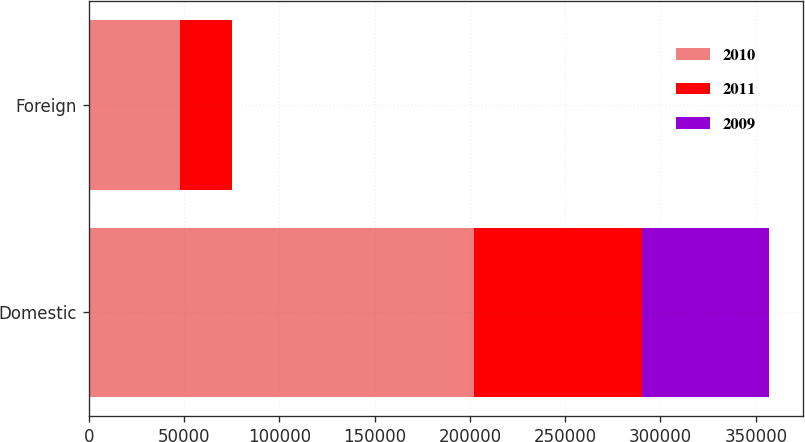Convert chart. <chart><loc_0><loc_0><loc_500><loc_500><stacked_bar_chart><ecel><fcel>Domestic<fcel>Foreign<nl><fcel>2010<fcel>202210<fcel>48006<nl><fcel>2011<fcel>88065<fcel>27103<nl><fcel>2009<fcel>66756<fcel>7<nl></chart> 